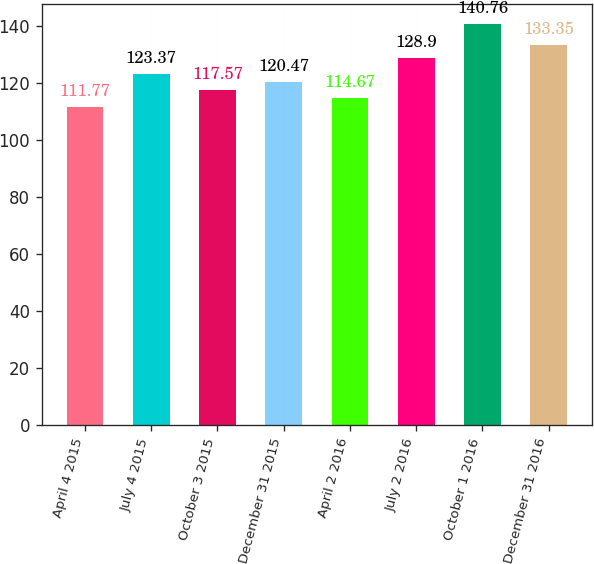Convert chart to OTSL. <chart><loc_0><loc_0><loc_500><loc_500><bar_chart><fcel>April 4 2015<fcel>July 4 2015<fcel>October 3 2015<fcel>December 31 2015<fcel>April 2 2016<fcel>July 2 2016<fcel>October 1 2016<fcel>December 31 2016<nl><fcel>111.77<fcel>123.37<fcel>117.57<fcel>120.47<fcel>114.67<fcel>128.9<fcel>140.76<fcel>133.35<nl></chart> 